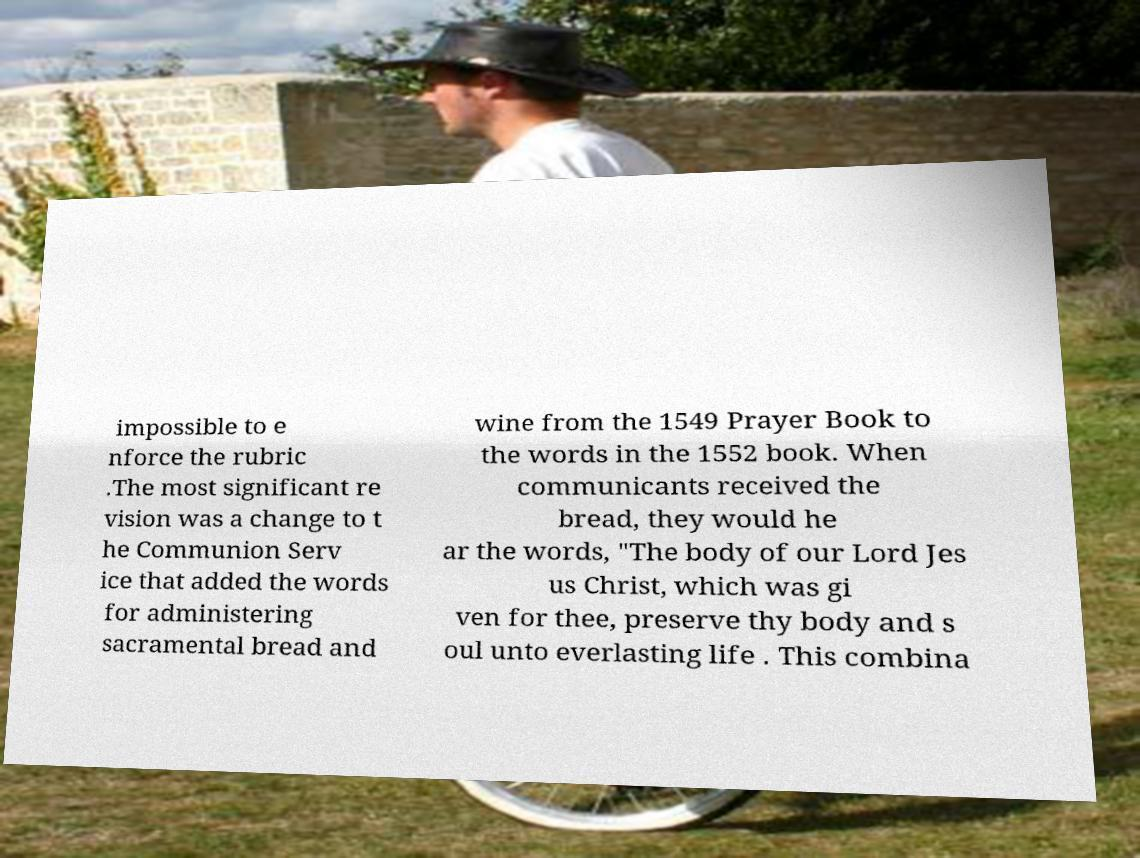Could you extract and type out the text from this image? impossible to e nforce the rubric .The most significant re vision was a change to t he Communion Serv ice that added the words for administering sacramental bread and wine from the 1549 Prayer Book to the words in the 1552 book. When communicants received the bread, they would he ar the words, "The body of our Lord Jes us Christ, which was gi ven for thee, preserve thy body and s oul unto everlasting life . This combina 